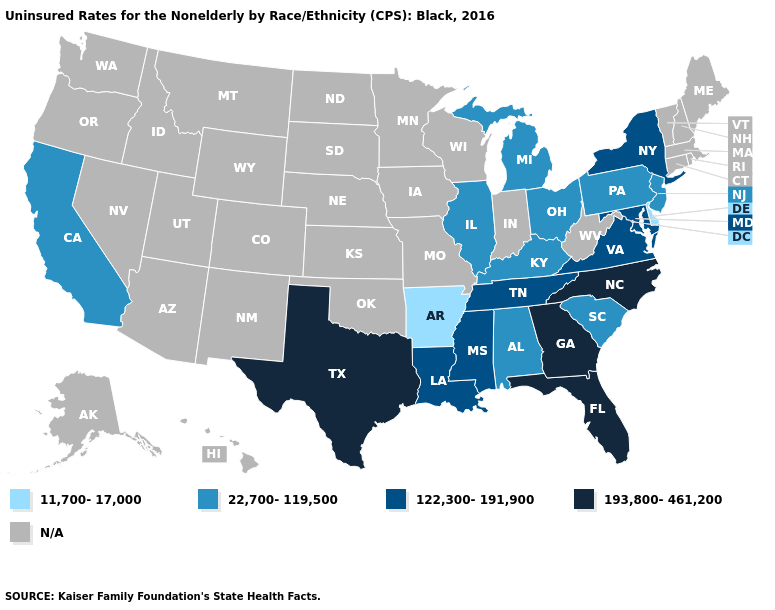What is the highest value in the South ?
Short answer required. 193,800-461,200. Is the legend a continuous bar?
Be succinct. No. What is the value of Ohio?
Give a very brief answer. 22,700-119,500. Does the map have missing data?
Short answer required. Yes. Does the first symbol in the legend represent the smallest category?
Be succinct. Yes. What is the value of Idaho?
Be succinct. N/A. Does Florida have the highest value in the USA?
Concise answer only. Yes. Does the map have missing data?
Concise answer only. Yes. Among the states that border Maryland , does Virginia have the highest value?
Keep it brief. Yes. What is the lowest value in states that border Pennsylvania?
Quick response, please. 11,700-17,000. How many symbols are there in the legend?
Short answer required. 5. Name the states that have a value in the range 193,800-461,200?
Short answer required. Florida, Georgia, North Carolina, Texas. Name the states that have a value in the range 122,300-191,900?
Give a very brief answer. Louisiana, Maryland, Mississippi, New York, Tennessee, Virginia. 